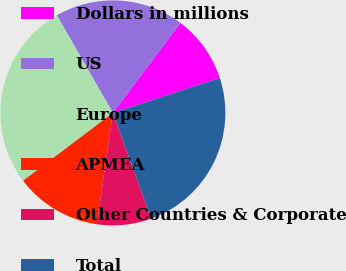<chart> <loc_0><loc_0><loc_500><loc_500><pie_chart><fcel>Dollars in millions<fcel>US<fcel>Europe<fcel>APMEA<fcel>Other Countries & Corporate<fcel>Total<nl><fcel>9.75%<fcel>18.54%<fcel>27.0%<fcel>12.41%<fcel>7.83%<fcel>24.46%<nl></chart> 